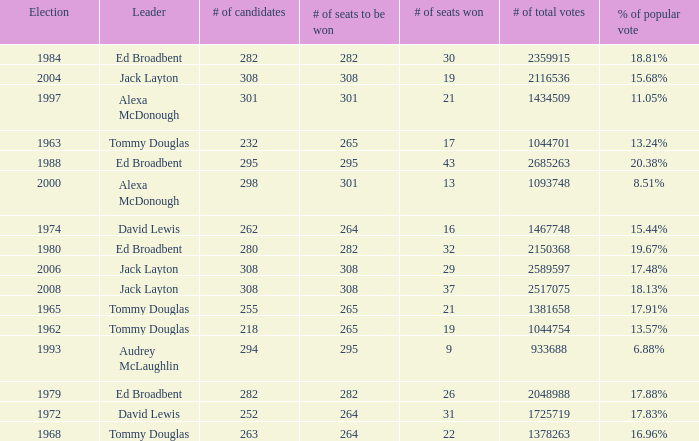Name the number of leaders for % of popular vote being 11.05% 1.0. 